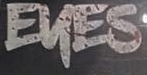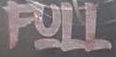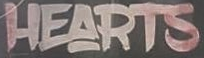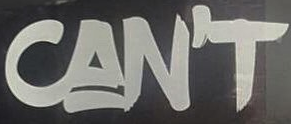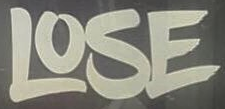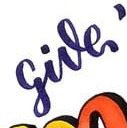Read the text content from these images in order, separated by a semicolon. EKES; FULL; HEARTS; CAN'T; LOSE; give 